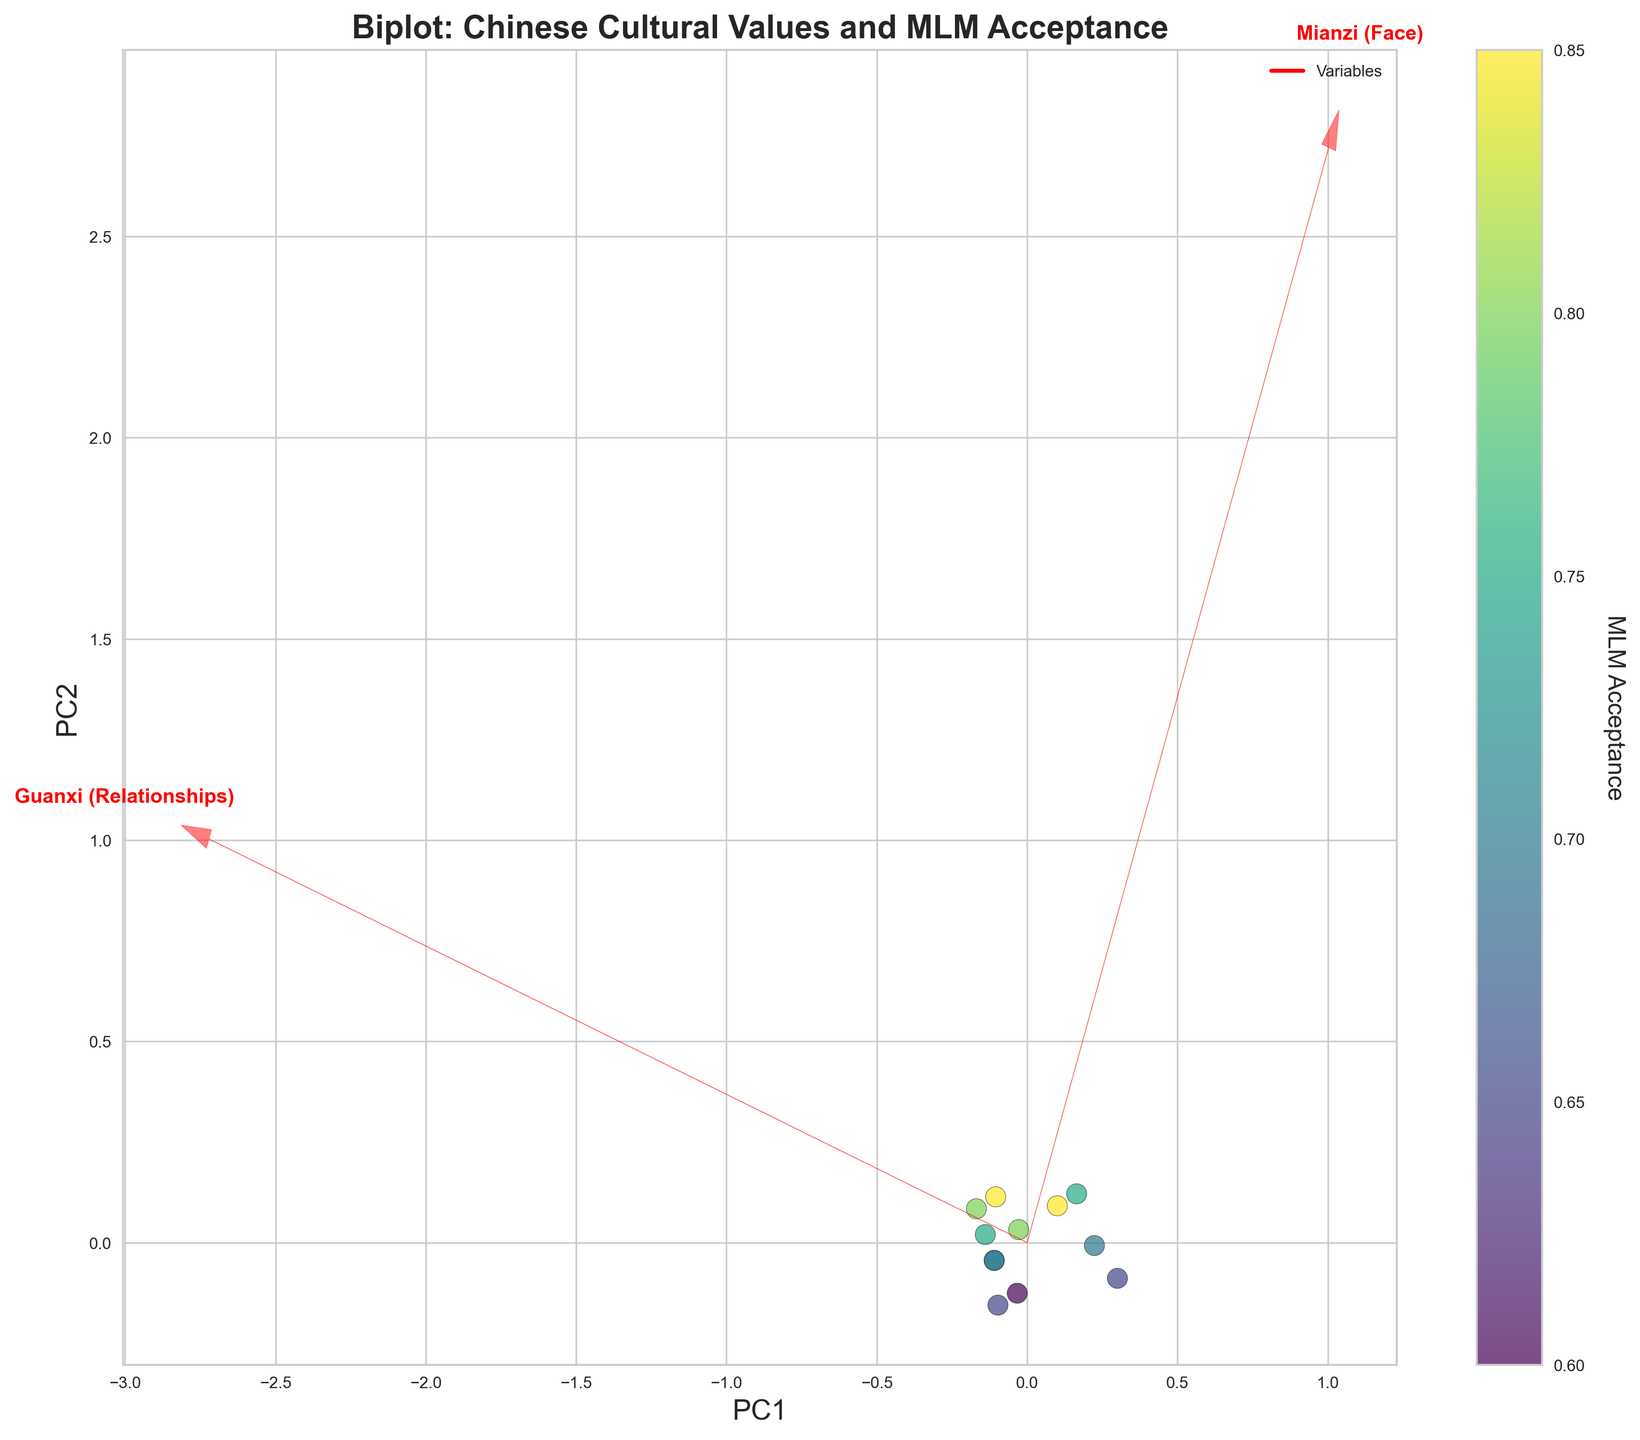What is the title of the figure? The title is displayed at the top of the figure. It provides a brief description of what the biplot represents. From the visual information, the title is "Biplot: Chinese Cultural Values and MLM Acceptance".
Answer: Biplot: Chinese Cultural Values and MLM Acceptance How are the color of the scatter points determined? The color of the scatter points varies and is mapped to the values of MLM Acceptance. This is indicated by the color bar on the right side of the figure labeled 'MLM Acceptance’.
Answer: By MLM Acceptance values Which cultural value is plotted farthest along the positive PC1 axis? The arrows for each variable indicate their relationship to the principal components. Filial piety (PC1) appears to be plotted farthest along the positive horizontal axis (PC1).
Answer: Filial piety How many variables are represented in the biplot? Each arrow and corresponding label represent a variable in the biplot. Counting the arrows and labels, we find there are 12 variables.
Answer: 12 Which variable is closest to the origin? The distance of each arrow from the origin indicates how strongly the variable contributes to the principal components. Materialism appears to be the closest to the origin.
Answer: Materialism Which cultural value has the highest influence on MLM Acceptance in traditional values? Looking at the loading vectors stretching from the origin, Collectivism shows the longest arrow in the positive direction for PC1, indicating the highest influence when considering traditional values.
Answer: Collectivism Is 'Entrepreneurship' more associated with traditional values or modern values? By observing the direction of the arrow for 'Entrepreneurship', it points more towards PC2, which is associated with modern values, showing a stronger alignment.
Answer: Modern values What does the plot suggest about the relationship between Hierarchy and Risk-taking regarding MLM Acceptance? The vector for Hierarchy points in a different direction compared to Risk-taking, indicating they are likely capturing different dimensions of MLM Acceptance. Specifically, Hierarchy is more associated with traditional values while Risk-taking aligns with modern values.
Answer: Different aspects Which cultural values are better correlated along both principal components? By looking at the alignment and length of the arrows, Collectivism and Entrepreneurship are well correlated along both PC1 and PC2, indicating they have strong contributions to both traditional and modern values as well as MLM Acceptance.
Answer: Collectivism and Entrepreneurship 